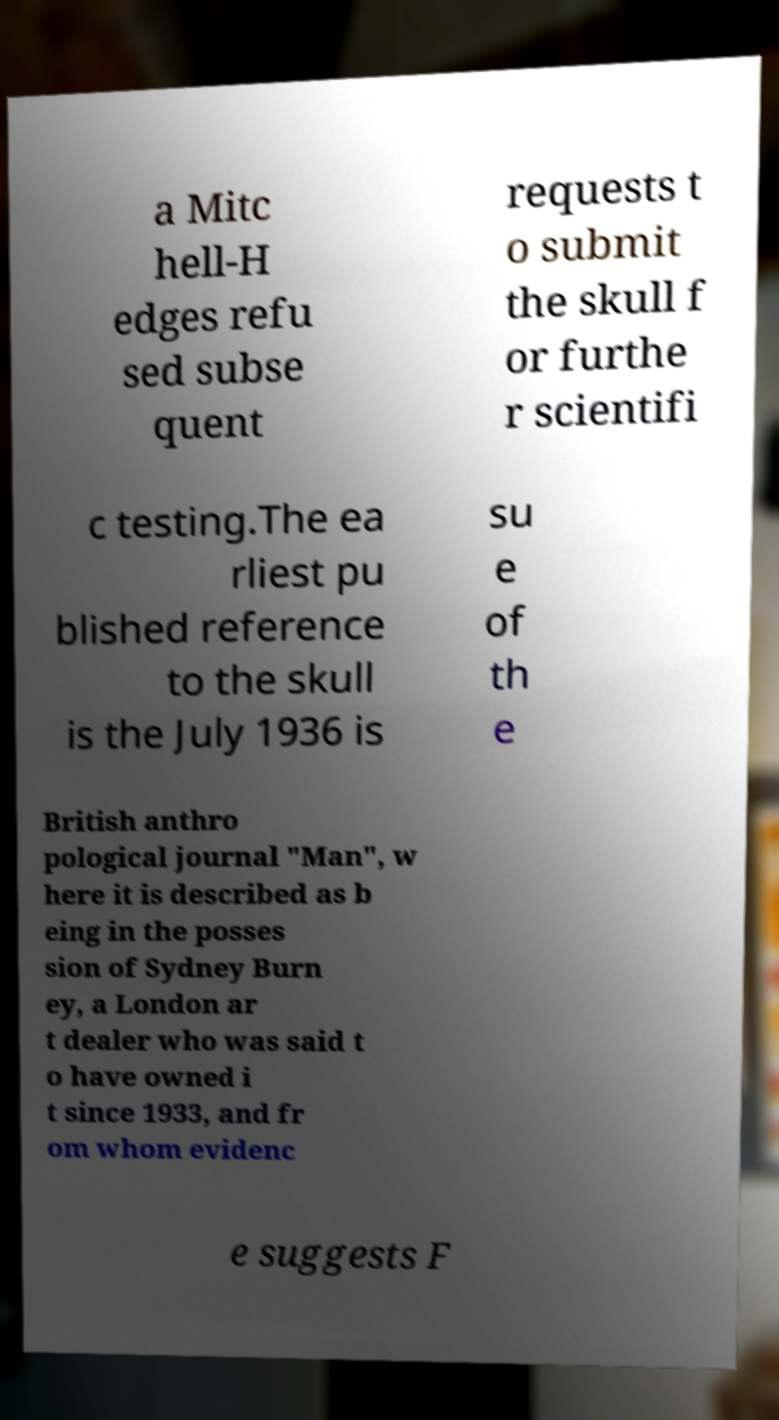There's text embedded in this image that I need extracted. Can you transcribe it verbatim? a Mitc hell-H edges refu sed subse quent requests t o submit the skull f or furthe r scientifi c testing.The ea rliest pu blished reference to the skull is the July 1936 is su e of th e British anthro pological journal "Man", w here it is described as b eing in the posses sion of Sydney Burn ey, a London ar t dealer who was said t o have owned i t since 1933, and fr om whom evidenc e suggests F 